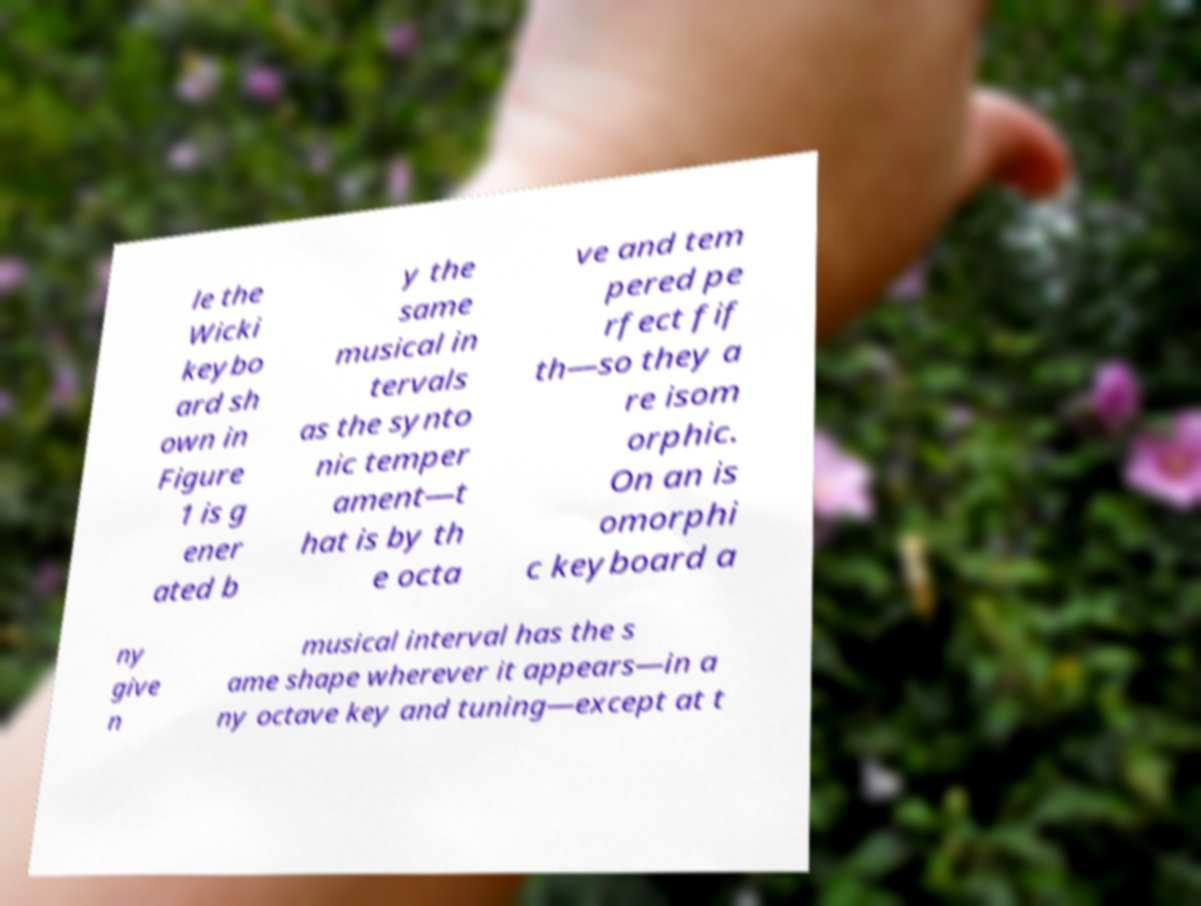Please identify and transcribe the text found in this image. le the Wicki keybo ard sh own in Figure 1 is g ener ated b y the same musical in tervals as the synto nic temper ament—t hat is by th e octa ve and tem pered pe rfect fif th—so they a re isom orphic. On an is omorphi c keyboard a ny give n musical interval has the s ame shape wherever it appears—in a ny octave key and tuning—except at t 